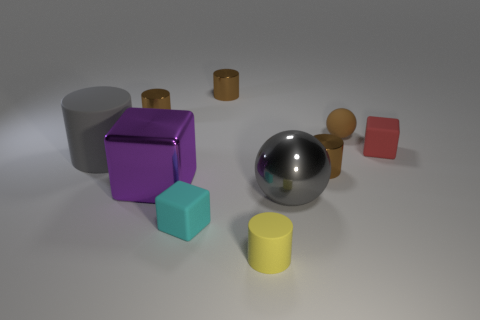Are there any big objects made of the same material as the big sphere?
Provide a short and direct response. Yes. Is the number of cyan objects greater than the number of tiny brown metallic objects?
Ensure brevity in your answer.  No. Is the large purple object made of the same material as the large gray sphere?
Make the answer very short. Yes. How many shiny objects are either red things or gray cubes?
Give a very brief answer. 0. There is a rubber cylinder that is the same size as the brown matte ball; what is its color?
Your response must be concise. Yellow. How many cyan rubber things have the same shape as the red matte thing?
Offer a very short reply. 1. What number of cylinders are either purple shiny things or cyan things?
Keep it short and to the point. 0. Is the shape of the large object that is right of the cyan block the same as the small matte object behind the red rubber thing?
Offer a terse response. Yes. What is the small red thing made of?
Provide a succinct answer. Rubber. There is a big metal object that is the same color as the big rubber object; what is its shape?
Make the answer very short. Sphere. 